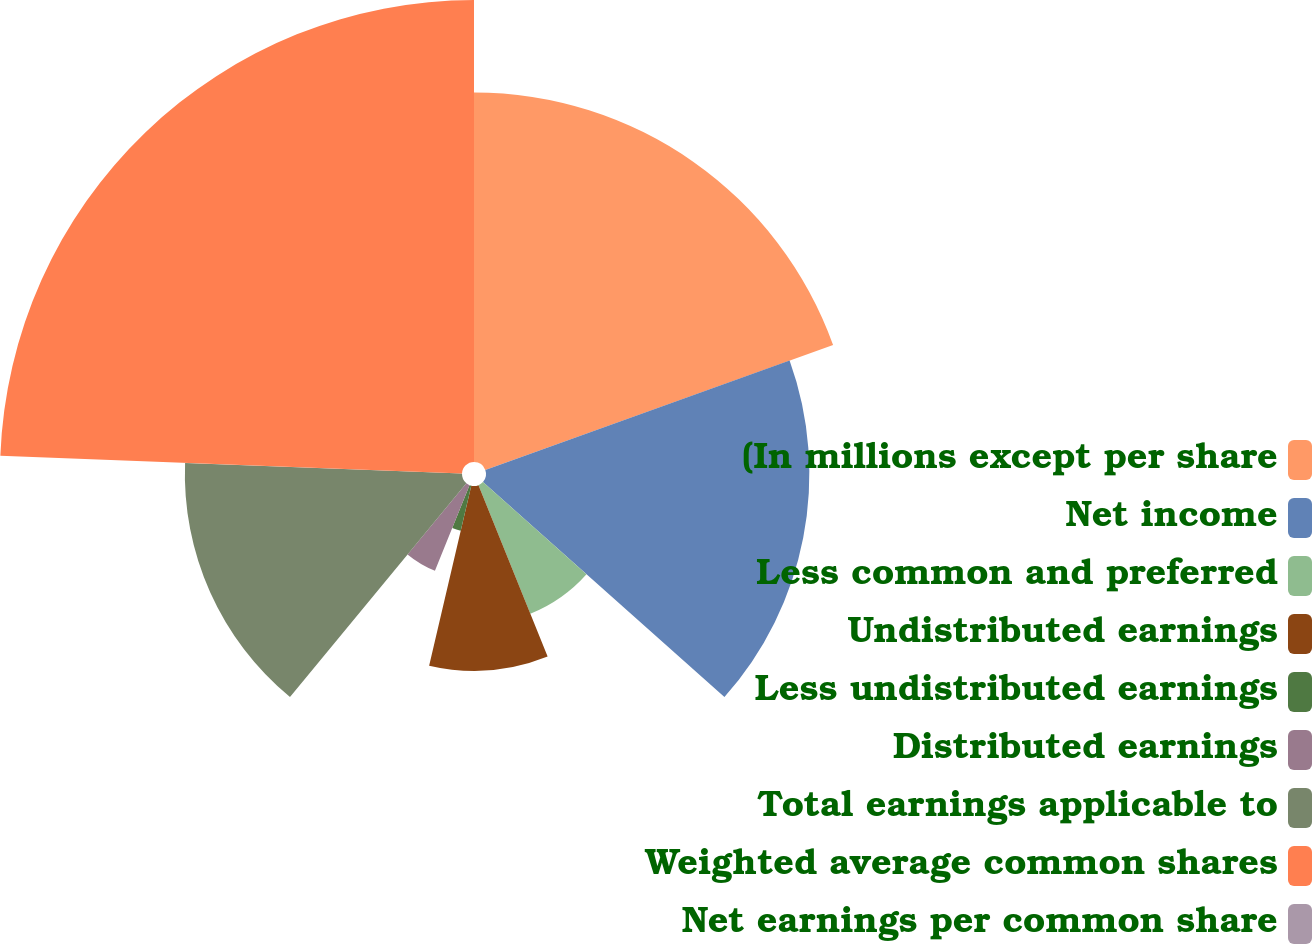Convert chart to OTSL. <chart><loc_0><loc_0><loc_500><loc_500><pie_chart><fcel>(In millions except per share<fcel>Net income<fcel>Less common and preferred<fcel>Undistributed earnings<fcel>Less undistributed earnings<fcel>Distributed earnings<fcel>Total earnings applicable to<fcel>Weighted average common shares<fcel>Net earnings per common share<nl><fcel>19.51%<fcel>17.07%<fcel>7.32%<fcel>9.76%<fcel>2.44%<fcel>4.88%<fcel>14.63%<fcel>24.39%<fcel>0.0%<nl></chart> 